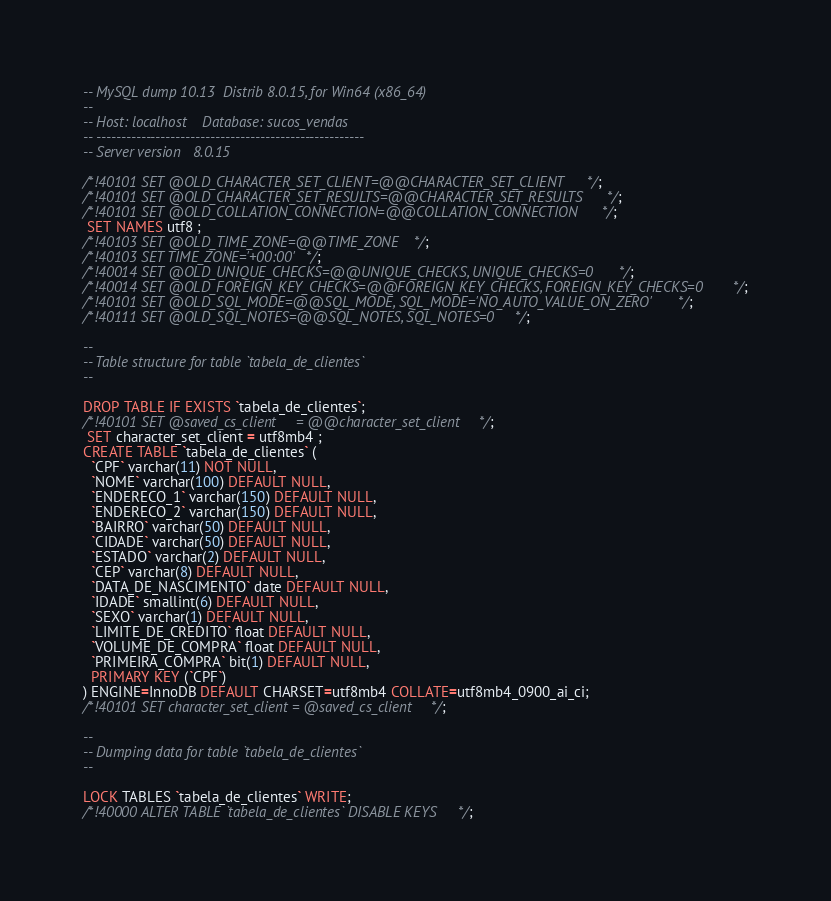Convert code to text. <code><loc_0><loc_0><loc_500><loc_500><_SQL_>-- MySQL dump 10.13  Distrib 8.0.15, for Win64 (x86_64)
--
-- Host: localhost    Database: sucos_vendas
-- ------------------------------------------------------
-- Server version	8.0.15

/*!40101 SET @OLD_CHARACTER_SET_CLIENT=@@CHARACTER_SET_CLIENT */;
/*!40101 SET @OLD_CHARACTER_SET_RESULTS=@@CHARACTER_SET_RESULTS */;
/*!40101 SET @OLD_COLLATION_CONNECTION=@@COLLATION_CONNECTION */;
 SET NAMES utf8 ;
/*!40103 SET @OLD_TIME_ZONE=@@TIME_ZONE */;
/*!40103 SET TIME_ZONE='+00:00' */;
/*!40014 SET @OLD_UNIQUE_CHECKS=@@UNIQUE_CHECKS, UNIQUE_CHECKS=0 */;
/*!40014 SET @OLD_FOREIGN_KEY_CHECKS=@@FOREIGN_KEY_CHECKS, FOREIGN_KEY_CHECKS=0 */;
/*!40101 SET @OLD_SQL_MODE=@@SQL_MODE, SQL_MODE='NO_AUTO_VALUE_ON_ZERO' */;
/*!40111 SET @OLD_SQL_NOTES=@@SQL_NOTES, SQL_NOTES=0 */;

--
-- Table structure for table `tabela_de_clientes`
--

DROP TABLE IF EXISTS `tabela_de_clientes`;
/*!40101 SET @saved_cs_client     = @@character_set_client */;
 SET character_set_client = utf8mb4 ;
CREATE TABLE `tabela_de_clientes` (
  `CPF` varchar(11) NOT NULL,
  `NOME` varchar(100) DEFAULT NULL,
  `ENDERECO_1` varchar(150) DEFAULT NULL,
  `ENDERECO_2` varchar(150) DEFAULT NULL,
  `BAIRRO` varchar(50) DEFAULT NULL,
  `CIDADE` varchar(50) DEFAULT NULL,
  `ESTADO` varchar(2) DEFAULT NULL,
  `CEP` varchar(8) DEFAULT NULL,
  `DATA_DE_NASCIMENTO` date DEFAULT NULL,
  `IDADE` smallint(6) DEFAULT NULL,
  `SEXO` varchar(1) DEFAULT NULL,
  `LIMITE_DE_CREDITO` float DEFAULT NULL,
  `VOLUME_DE_COMPRA` float DEFAULT NULL,
  `PRIMEIRA_COMPRA` bit(1) DEFAULT NULL,
  PRIMARY KEY (`CPF`)
) ENGINE=InnoDB DEFAULT CHARSET=utf8mb4 COLLATE=utf8mb4_0900_ai_ci;
/*!40101 SET character_set_client = @saved_cs_client */;

--
-- Dumping data for table `tabela_de_clientes`
--

LOCK TABLES `tabela_de_clientes` WRITE;
/*!40000 ALTER TABLE `tabela_de_clientes` DISABLE KEYS */;</code> 